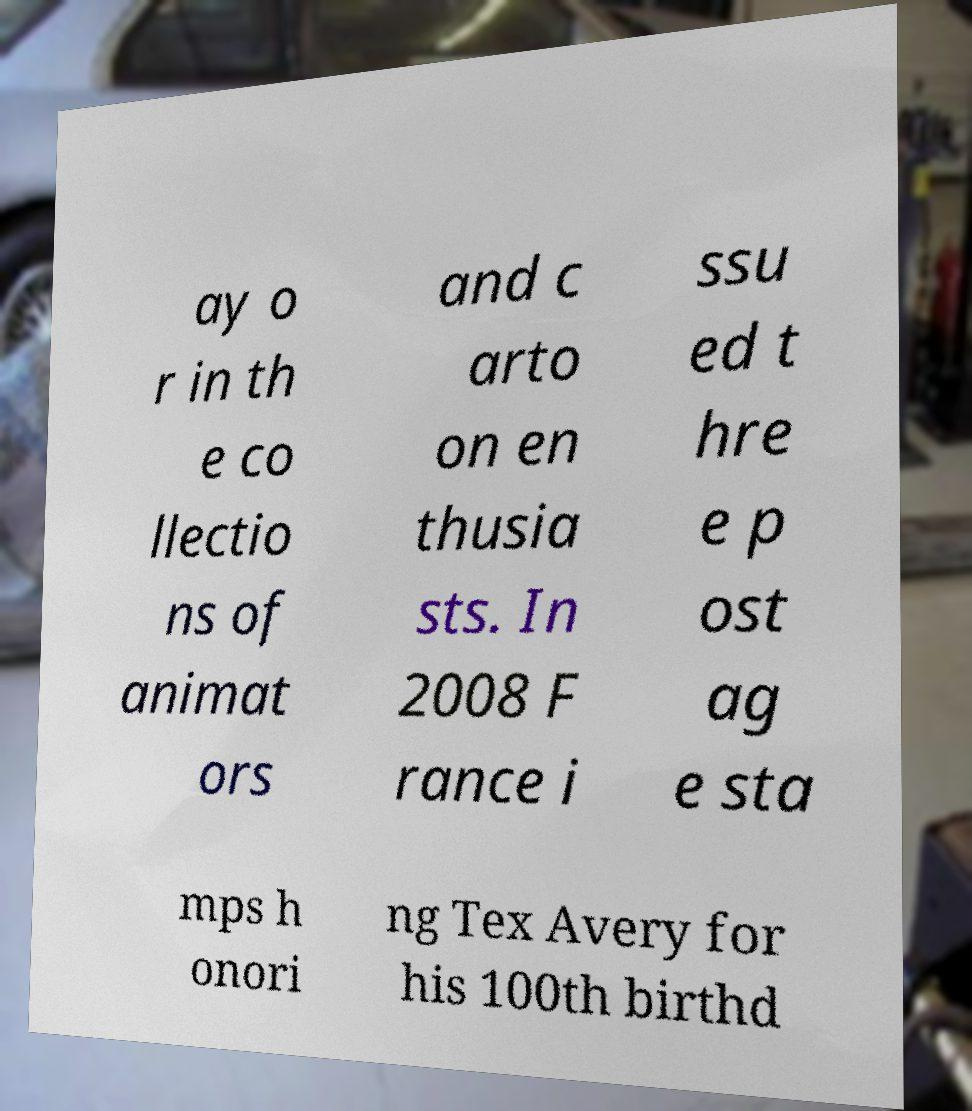Could you assist in decoding the text presented in this image and type it out clearly? ay o r in th e co llectio ns of animat ors and c arto on en thusia sts. In 2008 F rance i ssu ed t hre e p ost ag e sta mps h onori ng Tex Avery for his 100th birthd 